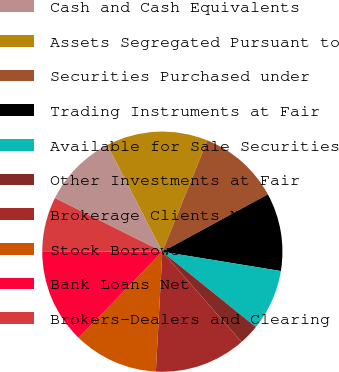Convert chart. <chart><loc_0><loc_0><loc_500><loc_500><pie_chart><fcel>Cash and Cash Equivalents<fcel>Assets Segregated Pursuant to<fcel>Securities Purchased under<fcel>Trading Instruments at Fair<fcel>Available for Sale Securities<fcel>Other Investments at Fair<fcel>Brokerage Clients Net<fcel>Stock Borrowed<fcel>Bank Loans Net<fcel>Brokers-Dealers and Clearing<nl><fcel>10.05%<fcel>13.7%<fcel>10.96%<fcel>10.5%<fcel>8.22%<fcel>2.74%<fcel>12.33%<fcel>11.42%<fcel>12.79%<fcel>7.31%<nl></chart> 